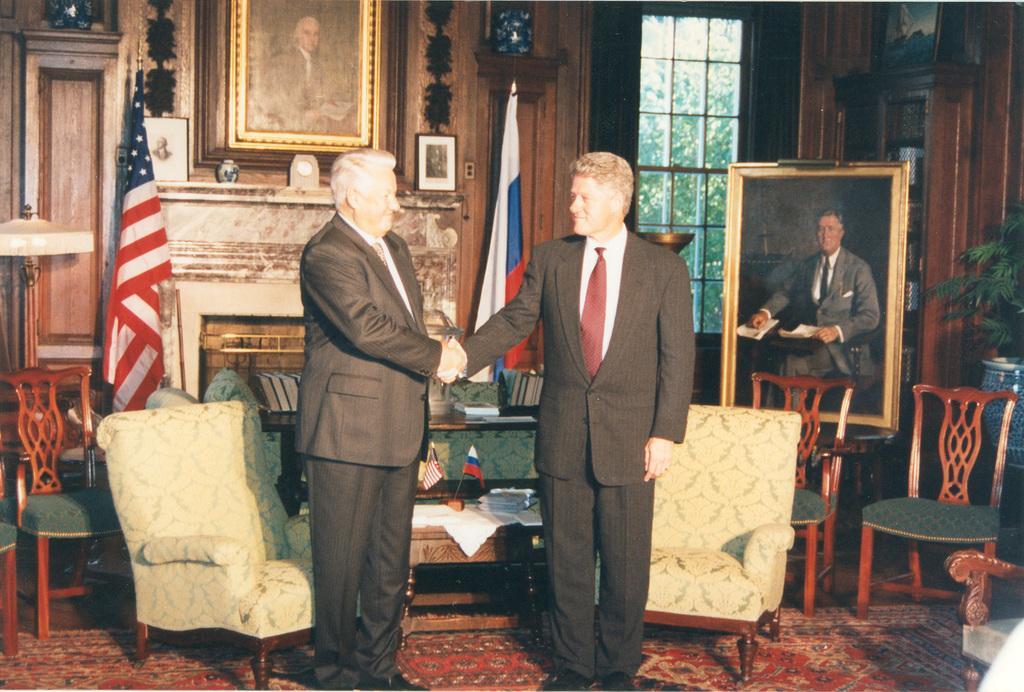In one or two sentences, can you explain what this image depicts? In this image I can see a man who is shaking hand with another man on the floor. I can also see a flag few chairs and photo painting on the right side. 